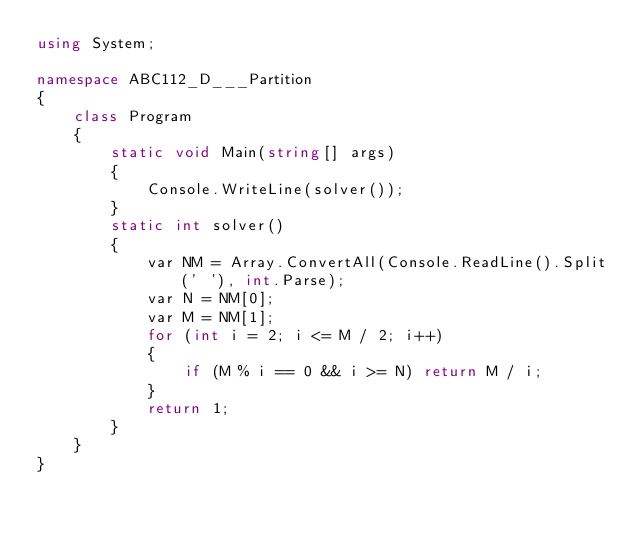<code> <loc_0><loc_0><loc_500><loc_500><_C#_>using System;

namespace ABC112_D___Partition
{
    class Program
    {
        static void Main(string[] args)
        {
            Console.WriteLine(solver());
        }
        static int solver()
        {
            var NM = Array.ConvertAll(Console.ReadLine().Split(' '), int.Parse);
            var N = NM[0];
            var M = NM[1];
            for (int i = 2; i <= M / 2; i++)
            {
                if (M % i == 0 && i >= N) return M / i;
            }
            return 1;
        }
    }
}
</code> 